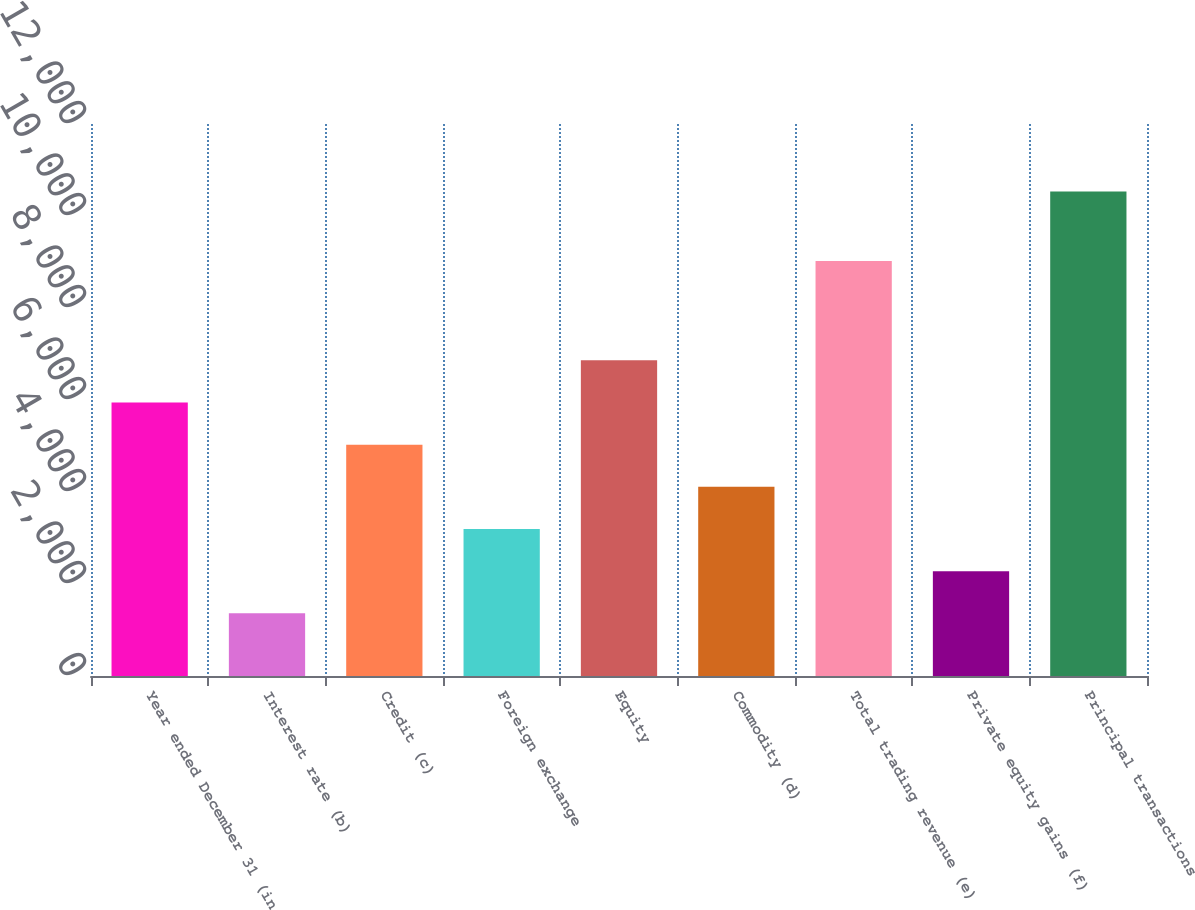Convert chart. <chart><loc_0><loc_0><loc_500><loc_500><bar_chart><fcel>Year ended December 31 (in<fcel>Interest rate (b)<fcel>Credit (c)<fcel>Foreign exchange<fcel>Equity<fcel>Commodity (d)<fcel>Total trading revenue (e)<fcel>Private equity gains (f)<fcel>Principal transactions<nl><fcel>5946.5<fcel>1362<fcel>5029.6<fcel>3195.8<fcel>6863.4<fcel>4112.7<fcel>9024<fcel>2278.9<fcel>10531<nl></chart> 